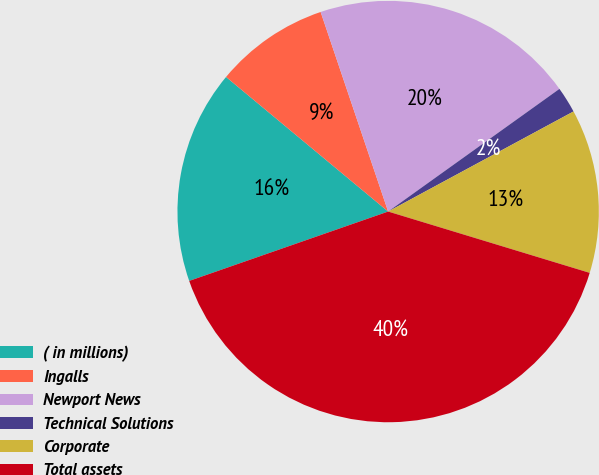Convert chart. <chart><loc_0><loc_0><loc_500><loc_500><pie_chart><fcel>( in millions)<fcel>Ingalls<fcel>Newport News<fcel>Technical Solutions<fcel>Corporate<fcel>Total assets<nl><fcel>16.37%<fcel>8.78%<fcel>20.3%<fcel>2.01%<fcel>12.58%<fcel>39.96%<nl></chart> 